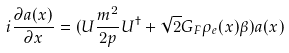Convert formula to latex. <formula><loc_0><loc_0><loc_500><loc_500>i \frac { \partial a ( x ) } { \partial x } = ( U \frac { m ^ { 2 } } { 2 p } U ^ { \dagger } + \sqrt { 2 } G _ { F } \rho _ { e } ( x ) \beta ) a ( x )</formula> 